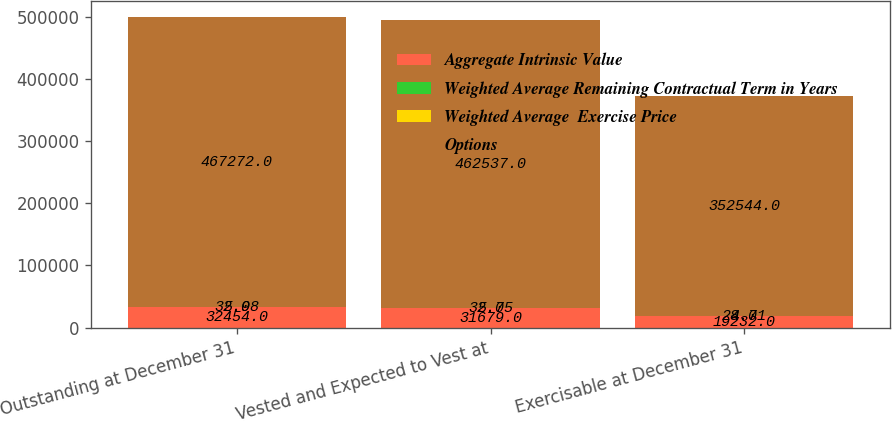<chart> <loc_0><loc_0><loc_500><loc_500><stacked_bar_chart><ecel><fcel>Outstanding at December 31<fcel>Vested and Expected to Vest at<fcel>Exercisable at December 31<nl><fcel>Aggregate Intrinsic Value<fcel>32454<fcel>31679<fcel>19232<nl><fcel>Weighted Average Remaining Contractual Term in Years<fcel>32.98<fcel>32.75<fcel>28.71<nl><fcel>Weighted Average  Exercise Price<fcel>5<fcel>5<fcel>4<nl><fcel>Options<fcel>467272<fcel>462537<fcel>352544<nl></chart> 